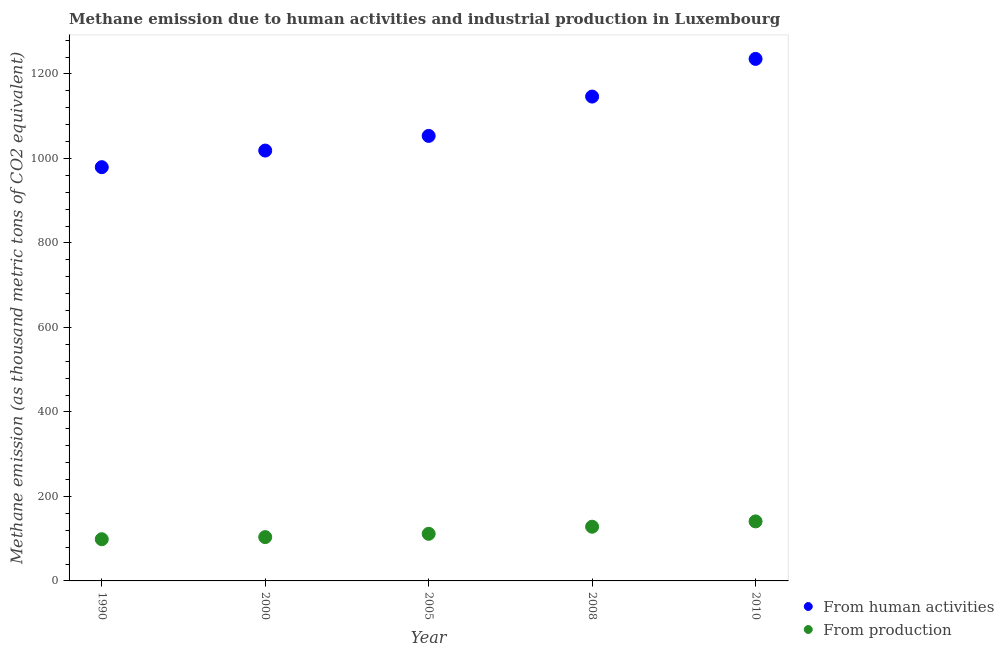How many different coloured dotlines are there?
Your answer should be compact. 2. Is the number of dotlines equal to the number of legend labels?
Offer a very short reply. Yes. What is the amount of emissions generated from industries in 2010?
Keep it short and to the point. 140.9. Across all years, what is the maximum amount of emissions generated from industries?
Ensure brevity in your answer.  140.9. Across all years, what is the minimum amount of emissions generated from industries?
Make the answer very short. 98.7. In which year was the amount of emissions generated from industries maximum?
Offer a very short reply. 2010. What is the total amount of emissions generated from industries in the graph?
Your response must be concise. 583.1. What is the difference between the amount of emissions generated from industries in 2000 and that in 2008?
Ensure brevity in your answer.  -24.6. What is the difference between the amount of emissions generated from industries in 2010 and the amount of emissions from human activities in 2000?
Make the answer very short. -877.8. What is the average amount of emissions from human activities per year?
Make the answer very short. 1086.74. In the year 2005, what is the difference between the amount of emissions from human activities and amount of emissions generated from industries?
Keep it short and to the point. 941.9. In how many years, is the amount of emissions from human activities greater than 1040 thousand metric tons?
Provide a short and direct response. 3. What is the ratio of the amount of emissions generated from industries in 2000 to that in 2005?
Make the answer very short. 0.93. What is the difference between the highest and the second highest amount of emissions from human activities?
Provide a short and direct response. 89.2. What is the difference between the highest and the lowest amount of emissions generated from industries?
Provide a succinct answer. 42.2. Is the sum of the amount of emissions from human activities in 2008 and 2010 greater than the maximum amount of emissions generated from industries across all years?
Offer a very short reply. Yes. Does the amount of emissions generated from industries monotonically increase over the years?
Ensure brevity in your answer.  Yes. Is the amount of emissions from human activities strictly greater than the amount of emissions generated from industries over the years?
Ensure brevity in your answer.  Yes. Is the amount of emissions generated from industries strictly less than the amount of emissions from human activities over the years?
Your answer should be compact. Yes. How many dotlines are there?
Offer a very short reply. 2. Does the graph contain any zero values?
Offer a very short reply. No. How many legend labels are there?
Give a very brief answer. 2. How are the legend labels stacked?
Offer a very short reply. Vertical. What is the title of the graph?
Give a very brief answer. Methane emission due to human activities and industrial production in Luxembourg. Does "Domestic liabilities" appear as one of the legend labels in the graph?
Offer a terse response. No. What is the label or title of the Y-axis?
Your answer should be compact. Methane emission (as thousand metric tons of CO2 equivalent). What is the Methane emission (as thousand metric tons of CO2 equivalent) in From human activities in 1990?
Your answer should be compact. 979.4. What is the Methane emission (as thousand metric tons of CO2 equivalent) in From production in 1990?
Make the answer very short. 98.7. What is the Methane emission (as thousand metric tons of CO2 equivalent) of From human activities in 2000?
Your answer should be compact. 1018.7. What is the Methane emission (as thousand metric tons of CO2 equivalent) in From production in 2000?
Your response must be concise. 103.7. What is the Methane emission (as thousand metric tons of CO2 equivalent) in From human activities in 2005?
Give a very brief answer. 1053.4. What is the Methane emission (as thousand metric tons of CO2 equivalent) in From production in 2005?
Offer a terse response. 111.5. What is the Methane emission (as thousand metric tons of CO2 equivalent) in From human activities in 2008?
Keep it short and to the point. 1146.5. What is the Methane emission (as thousand metric tons of CO2 equivalent) in From production in 2008?
Offer a very short reply. 128.3. What is the Methane emission (as thousand metric tons of CO2 equivalent) of From human activities in 2010?
Provide a succinct answer. 1235.7. What is the Methane emission (as thousand metric tons of CO2 equivalent) in From production in 2010?
Your response must be concise. 140.9. Across all years, what is the maximum Methane emission (as thousand metric tons of CO2 equivalent) in From human activities?
Provide a succinct answer. 1235.7. Across all years, what is the maximum Methane emission (as thousand metric tons of CO2 equivalent) in From production?
Give a very brief answer. 140.9. Across all years, what is the minimum Methane emission (as thousand metric tons of CO2 equivalent) of From human activities?
Ensure brevity in your answer.  979.4. Across all years, what is the minimum Methane emission (as thousand metric tons of CO2 equivalent) of From production?
Your answer should be very brief. 98.7. What is the total Methane emission (as thousand metric tons of CO2 equivalent) of From human activities in the graph?
Keep it short and to the point. 5433.7. What is the total Methane emission (as thousand metric tons of CO2 equivalent) in From production in the graph?
Keep it short and to the point. 583.1. What is the difference between the Methane emission (as thousand metric tons of CO2 equivalent) in From human activities in 1990 and that in 2000?
Your response must be concise. -39.3. What is the difference between the Methane emission (as thousand metric tons of CO2 equivalent) of From production in 1990 and that in 2000?
Your response must be concise. -5. What is the difference between the Methane emission (as thousand metric tons of CO2 equivalent) in From human activities in 1990 and that in 2005?
Keep it short and to the point. -74. What is the difference between the Methane emission (as thousand metric tons of CO2 equivalent) in From human activities in 1990 and that in 2008?
Your answer should be very brief. -167.1. What is the difference between the Methane emission (as thousand metric tons of CO2 equivalent) in From production in 1990 and that in 2008?
Keep it short and to the point. -29.6. What is the difference between the Methane emission (as thousand metric tons of CO2 equivalent) in From human activities in 1990 and that in 2010?
Provide a succinct answer. -256.3. What is the difference between the Methane emission (as thousand metric tons of CO2 equivalent) in From production in 1990 and that in 2010?
Make the answer very short. -42.2. What is the difference between the Methane emission (as thousand metric tons of CO2 equivalent) of From human activities in 2000 and that in 2005?
Ensure brevity in your answer.  -34.7. What is the difference between the Methane emission (as thousand metric tons of CO2 equivalent) in From production in 2000 and that in 2005?
Give a very brief answer. -7.8. What is the difference between the Methane emission (as thousand metric tons of CO2 equivalent) of From human activities in 2000 and that in 2008?
Provide a short and direct response. -127.8. What is the difference between the Methane emission (as thousand metric tons of CO2 equivalent) of From production in 2000 and that in 2008?
Your response must be concise. -24.6. What is the difference between the Methane emission (as thousand metric tons of CO2 equivalent) in From human activities in 2000 and that in 2010?
Make the answer very short. -217. What is the difference between the Methane emission (as thousand metric tons of CO2 equivalent) in From production in 2000 and that in 2010?
Keep it short and to the point. -37.2. What is the difference between the Methane emission (as thousand metric tons of CO2 equivalent) of From human activities in 2005 and that in 2008?
Offer a terse response. -93.1. What is the difference between the Methane emission (as thousand metric tons of CO2 equivalent) in From production in 2005 and that in 2008?
Provide a succinct answer. -16.8. What is the difference between the Methane emission (as thousand metric tons of CO2 equivalent) of From human activities in 2005 and that in 2010?
Ensure brevity in your answer.  -182.3. What is the difference between the Methane emission (as thousand metric tons of CO2 equivalent) in From production in 2005 and that in 2010?
Offer a terse response. -29.4. What is the difference between the Methane emission (as thousand metric tons of CO2 equivalent) of From human activities in 2008 and that in 2010?
Your answer should be very brief. -89.2. What is the difference between the Methane emission (as thousand metric tons of CO2 equivalent) of From production in 2008 and that in 2010?
Your response must be concise. -12.6. What is the difference between the Methane emission (as thousand metric tons of CO2 equivalent) of From human activities in 1990 and the Methane emission (as thousand metric tons of CO2 equivalent) of From production in 2000?
Your response must be concise. 875.7. What is the difference between the Methane emission (as thousand metric tons of CO2 equivalent) in From human activities in 1990 and the Methane emission (as thousand metric tons of CO2 equivalent) in From production in 2005?
Offer a terse response. 867.9. What is the difference between the Methane emission (as thousand metric tons of CO2 equivalent) of From human activities in 1990 and the Methane emission (as thousand metric tons of CO2 equivalent) of From production in 2008?
Offer a terse response. 851.1. What is the difference between the Methane emission (as thousand metric tons of CO2 equivalent) of From human activities in 1990 and the Methane emission (as thousand metric tons of CO2 equivalent) of From production in 2010?
Your answer should be very brief. 838.5. What is the difference between the Methane emission (as thousand metric tons of CO2 equivalent) in From human activities in 2000 and the Methane emission (as thousand metric tons of CO2 equivalent) in From production in 2005?
Your response must be concise. 907.2. What is the difference between the Methane emission (as thousand metric tons of CO2 equivalent) of From human activities in 2000 and the Methane emission (as thousand metric tons of CO2 equivalent) of From production in 2008?
Your answer should be compact. 890.4. What is the difference between the Methane emission (as thousand metric tons of CO2 equivalent) of From human activities in 2000 and the Methane emission (as thousand metric tons of CO2 equivalent) of From production in 2010?
Ensure brevity in your answer.  877.8. What is the difference between the Methane emission (as thousand metric tons of CO2 equivalent) of From human activities in 2005 and the Methane emission (as thousand metric tons of CO2 equivalent) of From production in 2008?
Offer a very short reply. 925.1. What is the difference between the Methane emission (as thousand metric tons of CO2 equivalent) of From human activities in 2005 and the Methane emission (as thousand metric tons of CO2 equivalent) of From production in 2010?
Your answer should be compact. 912.5. What is the difference between the Methane emission (as thousand metric tons of CO2 equivalent) of From human activities in 2008 and the Methane emission (as thousand metric tons of CO2 equivalent) of From production in 2010?
Provide a short and direct response. 1005.6. What is the average Methane emission (as thousand metric tons of CO2 equivalent) of From human activities per year?
Ensure brevity in your answer.  1086.74. What is the average Methane emission (as thousand metric tons of CO2 equivalent) in From production per year?
Give a very brief answer. 116.62. In the year 1990, what is the difference between the Methane emission (as thousand metric tons of CO2 equivalent) of From human activities and Methane emission (as thousand metric tons of CO2 equivalent) of From production?
Give a very brief answer. 880.7. In the year 2000, what is the difference between the Methane emission (as thousand metric tons of CO2 equivalent) in From human activities and Methane emission (as thousand metric tons of CO2 equivalent) in From production?
Give a very brief answer. 915. In the year 2005, what is the difference between the Methane emission (as thousand metric tons of CO2 equivalent) of From human activities and Methane emission (as thousand metric tons of CO2 equivalent) of From production?
Give a very brief answer. 941.9. In the year 2008, what is the difference between the Methane emission (as thousand metric tons of CO2 equivalent) of From human activities and Methane emission (as thousand metric tons of CO2 equivalent) of From production?
Your answer should be very brief. 1018.2. In the year 2010, what is the difference between the Methane emission (as thousand metric tons of CO2 equivalent) of From human activities and Methane emission (as thousand metric tons of CO2 equivalent) of From production?
Your answer should be very brief. 1094.8. What is the ratio of the Methane emission (as thousand metric tons of CO2 equivalent) of From human activities in 1990 to that in 2000?
Your answer should be compact. 0.96. What is the ratio of the Methane emission (as thousand metric tons of CO2 equivalent) in From production in 1990 to that in 2000?
Make the answer very short. 0.95. What is the ratio of the Methane emission (as thousand metric tons of CO2 equivalent) of From human activities in 1990 to that in 2005?
Offer a very short reply. 0.93. What is the ratio of the Methane emission (as thousand metric tons of CO2 equivalent) of From production in 1990 to that in 2005?
Give a very brief answer. 0.89. What is the ratio of the Methane emission (as thousand metric tons of CO2 equivalent) in From human activities in 1990 to that in 2008?
Offer a very short reply. 0.85. What is the ratio of the Methane emission (as thousand metric tons of CO2 equivalent) in From production in 1990 to that in 2008?
Your answer should be very brief. 0.77. What is the ratio of the Methane emission (as thousand metric tons of CO2 equivalent) in From human activities in 1990 to that in 2010?
Offer a terse response. 0.79. What is the ratio of the Methane emission (as thousand metric tons of CO2 equivalent) in From production in 1990 to that in 2010?
Your response must be concise. 0.7. What is the ratio of the Methane emission (as thousand metric tons of CO2 equivalent) of From human activities in 2000 to that in 2005?
Offer a very short reply. 0.97. What is the ratio of the Methane emission (as thousand metric tons of CO2 equivalent) in From production in 2000 to that in 2005?
Offer a terse response. 0.93. What is the ratio of the Methane emission (as thousand metric tons of CO2 equivalent) of From human activities in 2000 to that in 2008?
Your answer should be compact. 0.89. What is the ratio of the Methane emission (as thousand metric tons of CO2 equivalent) in From production in 2000 to that in 2008?
Offer a terse response. 0.81. What is the ratio of the Methane emission (as thousand metric tons of CO2 equivalent) in From human activities in 2000 to that in 2010?
Offer a very short reply. 0.82. What is the ratio of the Methane emission (as thousand metric tons of CO2 equivalent) of From production in 2000 to that in 2010?
Offer a terse response. 0.74. What is the ratio of the Methane emission (as thousand metric tons of CO2 equivalent) in From human activities in 2005 to that in 2008?
Provide a short and direct response. 0.92. What is the ratio of the Methane emission (as thousand metric tons of CO2 equivalent) in From production in 2005 to that in 2008?
Your answer should be compact. 0.87. What is the ratio of the Methane emission (as thousand metric tons of CO2 equivalent) in From human activities in 2005 to that in 2010?
Your response must be concise. 0.85. What is the ratio of the Methane emission (as thousand metric tons of CO2 equivalent) of From production in 2005 to that in 2010?
Your response must be concise. 0.79. What is the ratio of the Methane emission (as thousand metric tons of CO2 equivalent) in From human activities in 2008 to that in 2010?
Make the answer very short. 0.93. What is the ratio of the Methane emission (as thousand metric tons of CO2 equivalent) in From production in 2008 to that in 2010?
Ensure brevity in your answer.  0.91. What is the difference between the highest and the second highest Methane emission (as thousand metric tons of CO2 equivalent) in From human activities?
Offer a terse response. 89.2. What is the difference between the highest and the lowest Methane emission (as thousand metric tons of CO2 equivalent) in From human activities?
Ensure brevity in your answer.  256.3. What is the difference between the highest and the lowest Methane emission (as thousand metric tons of CO2 equivalent) in From production?
Provide a succinct answer. 42.2. 